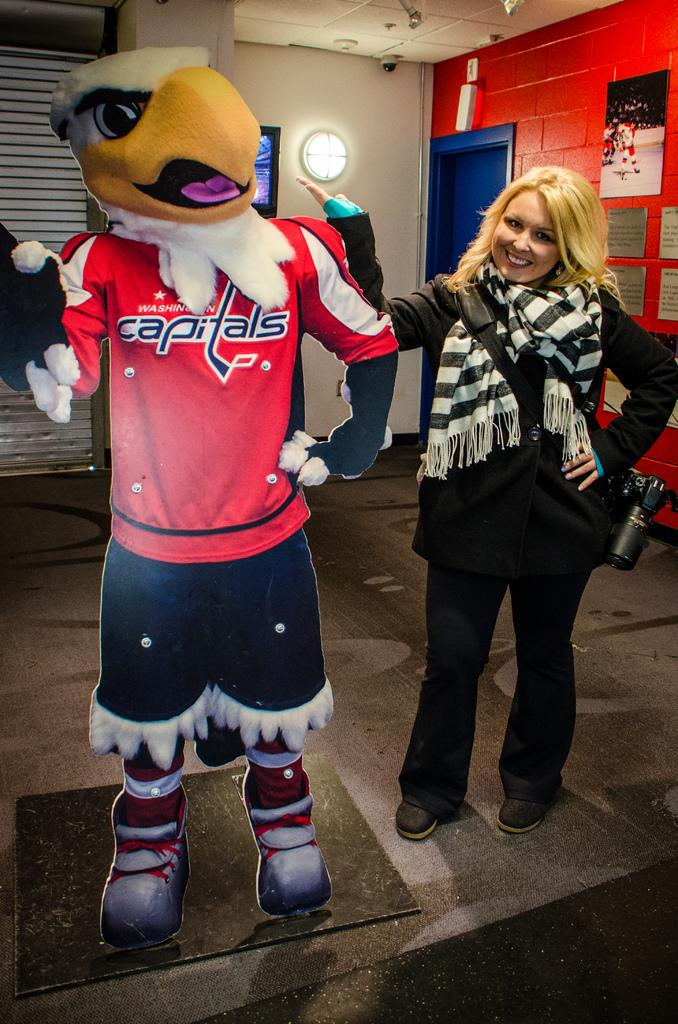<image>
Provide a brief description of the given image. A blonde woman standing next to a cardboard cutout of an eagle in a Capitals jerseys. 